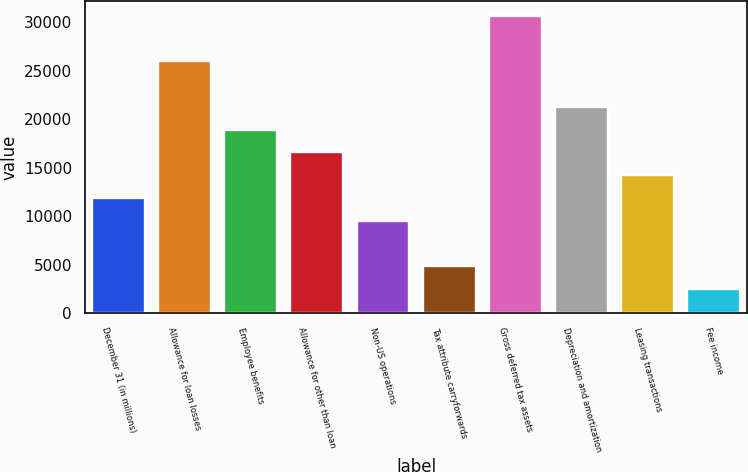Convert chart to OTSL. <chart><loc_0><loc_0><loc_500><loc_500><bar_chart><fcel>December 31 (in millions)<fcel>Allowance for loan losses<fcel>Employee benefits<fcel>Allowance for other than loan<fcel>Non-US operations<fcel>Tax attribute carryforwards<fcel>Gross deferred tax assets<fcel>Depreciation and amortization<fcel>Leasing transactions<fcel>Fee income<nl><fcel>11890<fcel>25981.6<fcel>18935.8<fcel>16587.2<fcel>9541.4<fcel>4844.2<fcel>30678.8<fcel>21284.4<fcel>14238.6<fcel>2495.6<nl></chart> 